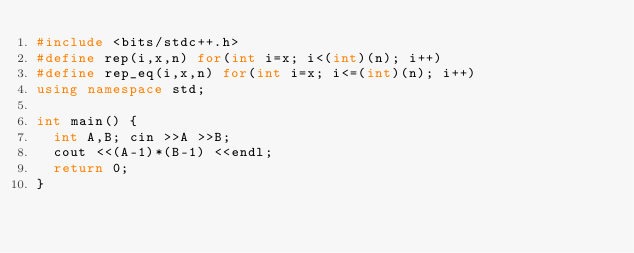Convert code to text. <code><loc_0><loc_0><loc_500><loc_500><_C++_>#include <bits/stdc++.h>
#define rep(i,x,n) for(int i=x; i<(int)(n); i++)
#define rep_eq(i,x,n) for(int i=x; i<=(int)(n); i++)
using namespace std;

int main() {
  int A,B; cin >>A >>B;
  cout <<(A-1)*(B-1) <<endl;
  return 0;
}
</code> 